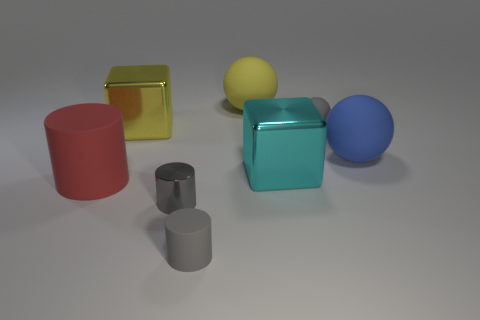How many gray cylinders must be subtracted to get 1 gray cylinders? 1 Add 2 large rubber cylinders. How many objects exist? 10 Subtract all cylinders. How many objects are left? 5 Add 8 blue matte things. How many blue matte things exist? 9 Subtract 0 purple blocks. How many objects are left? 8 Subtract all cyan metallic things. Subtract all small metallic objects. How many objects are left? 6 Add 8 large cyan cubes. How many large cyan cubes are left? 9 